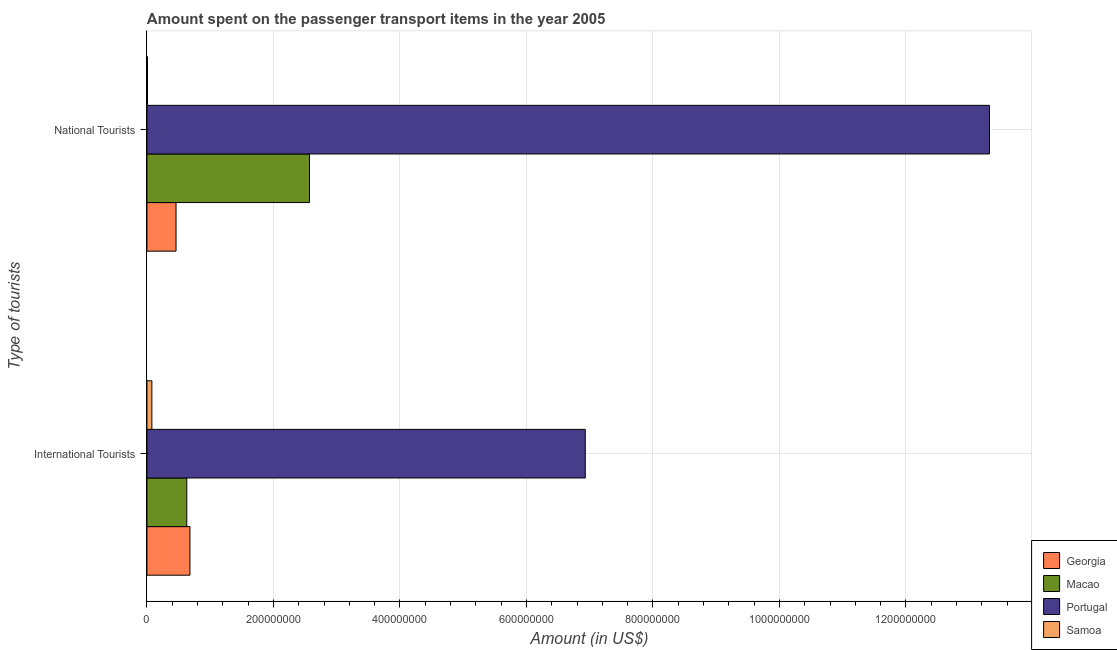Are the number of bars per tick equal to the number of legend labels?
Offer a very short reply. Yes. How many bars are there on the 2nd tick from the bottom?
Offer a very short reply. 4. What is the label of the 1st group of bars from the top?
Offer a terse response. National Tourists. What is the amount spent on transport items of national tourists in Macao?
Make the answer very short. 2.57e+08. Across all countries, what is the maximum amount spent on transport items of national tourists?
Provide a succinct answer. 1.33e+09. Across all countries, what is the minimum amount spent on transport items of national tourists?
Your answer should be very brief. 8.00e+05. In which country was the amount spent on transport items of national tourists maximum?
Offer a terse response. Portugal. In which country was the amount spent on transport items of international tourists minimum?
Your response must be concise. Samoa. What is the total amount spent on transport items of national tourists in the graph?
Give a very brief answer. 1.64e+09. What is the difference between the amount spent on transport items of international tourists in Samoa and that in Georgia?
Your response must be concise. -6.02e+07. What is the difference between the amount spent on transport items of international tourists in Samoa and the amount spent on transport items of national tourists in Georgia?
Provide a succinct answer. -3.82e+07. What is the average amount spent on transport items of national tourists per country?
Ensure brevity in your answer.  4.09e+08. What is the difference between the amount spent on transport items of international tourists and amount spent on transport items of national tourists in Portugal?
Provide a short and direct response. -6.39e+08. In how many countries, is the amount spent on transport items of national tourists greater than 520000000 US$?
Your response must be concise. 1. What is the ratio of the amount spent on transport items of international tourists in Macao to that in Georgia?
Your answer should be very brief. 0.93. What does the 2nd bar from the top in National Tourists represents?
Keep it short and to the point. Portugal. How many bars are there?
Offer a very short reply. 8. Are all the bars in the graph horizontal?
Keep it short and to the point. Yes. How many countries are there in the graph?
Ensure brevity in your answer.  4. What is the difference between two consecutive major ticks on the X-axis?
Your answer should be very brief. 2.00e+08. Does the graph contain any zero values?
Ensure brevity in your answer.  No. Does the graph contain grids?
Provide a succinct answer. Yes. Where does the legend appear in the graph?
Provide a succinct answer. Bottom right. What is the title of the graph?
Offer a terse response. Amount spent on the passenger transport items in the year 2005. What is the label or title of the Y-axis?
Provide a succinct answer. Type of tourists. What is the Amount (in US$) in Georgia in International Tourists?
Keep it short and to the point. 6.80e+07. What is the Amount (in US$) in Macao in International Tourists?
Give a very brief answer. 6.30e+07. What is the Amount (in US$) of Portugal in International Tourists?
Offer a very short reply. 6.93e+08. What is the Amount (in US$) of Samoa in International Tourists?
Provide a succinct answer. 7.80e+06. What is the Amount (in US$) in Georgia in National Tourists?
Give a very brief answer. 4.60e+07. What is the Amount (in US$) in Macao in National Tourists?
Provide a succinct answer. 2.57e+08. What is the Amount (in US$) of Portugal in National Tourists?
Your answer should be very brief. 1.33e+09. What is the Amount (in US$) of Samoa in National Tourists?
Your answer should be compact. 8.00e+05. Across all Type of tourists, what is the maximum Amount (in US$) of Georgia?
Your answer should be compact. 6.80e+07. Across all Type of tourists, what is the maximum Amount (in US$) of Macao?
Provide a short and direct response. 2.57e+08. Across all Type of tourists, what is the maximum Amount (in US$) in Portugal?
Provide a succinct answer. 1.33e+09. Across all Type of tourists, what is the maximum Amount (in US$) in Samoa?
Provide a short and direct response. 7.80e+06. Across all Type of tourists, what is the minimum Amount (in US$) of Georgia?
Ensure brevity in your answer.  4.60e+07. Across all Type of tourists, what is the minimum Amount (in US$) in Macao?
Ensure brevity in your answer.  6.30e+07. Across all Type of tourists, what is the minimum Amount (in US$) of Portugal?
Your response must be concise. 6.93e+08. Across all Type of tourists, what is the minimum Amount (in US$) in Samoa?
Provide a short and direct response. 8.00e+05. What is the total Amount (in US$) in Georgia in the graph?
Keep it short and to the point. 1.14e+08. What is the total Amount (in US$) in Macao in the graph?
Make the answer very short. 3.20e+08. What is the total Amount (in US$) in Portugal in the graph?
Provide a short and direct response. 2.02e+09. What is the total Amount (in US$) in Samoa in the graph?
Keep it short and to the point. 8.60e+06. What is the difference between the Amount (in US$) in Georgia in International Tourists and that in National Tourists?
Offer a terse response. 2.20e+07. What is the difference between the Amount (in US$) in Macao in International Tourists and that in National Tourists?
Make the answer very short. -1.94e+08. What is the difference between the Amount (in US$) in Portugal in International Tourists and that in National Tourists?
Make the answer very short. -6.39e+08. What is the difference between the Amount (in US$) in Georgia in International Tourists and the Amount (in US$) in Macao in National Tourists?
Ensure brevity in your answer.  -1.89e+08. What is the difference between the Amount (in US$) of Georgia in International Tourists and the Amount (in US$) of Portugal in National Tourists?
Your response must be concise. -1.26e+09. What is the difference between the Amount (in US$) of Georgia in International Tourists and the Amount (in US$) of Samoa in National Tourists?
Give a very brief answer. 6.72e+07. What is the difference between the Amount (in US$) of Macao in International Tourists and the Amount (in US$) of Portugal in National Tourists?
Ensure brevity in your answer.  -1.27e+09. What is the difference between the Amount (in US$) in Macao in International Tourists and the Amount (in US$) in Samoa in National Tourists?
Your answer should be compact. 6.22e+07. What is the difference between the Amount (in US$) of Portugal in International Tourists and the Amount (in US$) of Samoa in National Tourists?
Offer a terse response. 6.92e+08. What is the average Amount (in US$) of Georgia per Type of tourists?
Ensure brevity in your answer.  5.70e+07. What is the average Amount (in US$) in Macao per Type of tourists?
Offer a very short reply. 1.60e+08. What is the average Amount (in US$) in Portugal per Type of tourists?
Give a very brief answer. 1.01e+09. What is the average Amount (in US$) in Samoa per Type of tourists?
Provide a succinct answer. 4.30e+06. What is the difference between the Amount (in US$) in Georgia and Amount (in US$) in Portugal in International Tourists?
Give a very brief answer. -6.25e+08. What is the difference between the Amount (in US$) in Georgia and Amount (in US$) in Samoa in International Tourists?
Provide a short and direct response. 6.02e+07. What is the difference between the Amount (in US$) in Macao and Amount (in US$) in Portugal in International Tourists?
Your answer should be compact. -6.30e+08. What is the difference between the Amount (in US$) of Macao and Amount (in US$) of Samoa in International Tourists?
Offer a terse response. 5.52e+07. What is the difference between the Amount (in US$) of Portugal and Amount (in US$) of Samoa in International Tourists?
Offer a terse response. 6.85e+08. What is the difference between the Amount (in US$) of Georgia and Amount (in US$) of Macao in National Tourists?
Make the answer very short. -2.11e+08. What is the difference between the Amount (in US$) in Georgia and Amount (in US$) in Portugal in National Tourists?
Ensure brevity in your answer.  -1.29e+09. What is the difference between the Amount (in US$) of Georgia and Amount (in US$) of Samoa in National Tourists?
Your answer should be compact. 4.52e+07. What is the difference between the Amount (in US$) of Macao and Amount (in US$) of Portugal in National Tourists?
Make the answer very short. -1.08e+09. What is the difference between the Amount (in US$) in Macao and Amount (in US$) in Samoa in National Tourists?
Make the answer very short. 2.56e+08. What is the difference between the Amount (in US$) in Portugal and Amount (in US$) in Samoa in National Tourists?
Your response must be concise. 1.33e+09. What is the ratio of the Amount (in US$) of Georgia in International Tourists to that in National Tourists?
Keep it short and to the point. 1.48. What is the ratio of the Amount (in US$) in Macao in International Tourists to that in National Tourists?
Your response must be concise. 0.25. What is the ratio of the Amount (in US$) in Portugal in International Tourists to that in National Tourists?
Give a very brief answer. 0.52. What is the ratio of the Amount (in US$) in Samoa in International Tourists to that in National Tourists?
Your answer should be compact. 9.75. What is the difference between the highest and the second highest Amount (in US$) of Georgia?
Ensure brevity in your answer.  2.20e+07. What is the difference between the highest and the second highest Amount (in US$) of Macao?
Keep it short and to the point. 1.94e+08. What is the difference between the highest and the second highest Amount (in US$) of Portugal?
Offer a terse response. 6.39e+08. What is the difference between the highest and the second highest Amount (in US$) of Samoa?
Offer a very short reply. 7.00e+06. What is the difference between the highest and the lowest Amount (in US$) of Georgia?
Your answer should be very brief. 2.20e+07. What is the difference between the highest and the lowest Amount (in US$) of Macao?
Your answer should be very brief. 1.94e+08. What is the difference between the highest and the lowest Amount (in US$) in Portugal?
Provide a short and direct response. 6.39e+08. What is the difference between the highest and the lowest Amount (in US$) of Samoa?
Keep it short and to the point. 7.00e+06. 